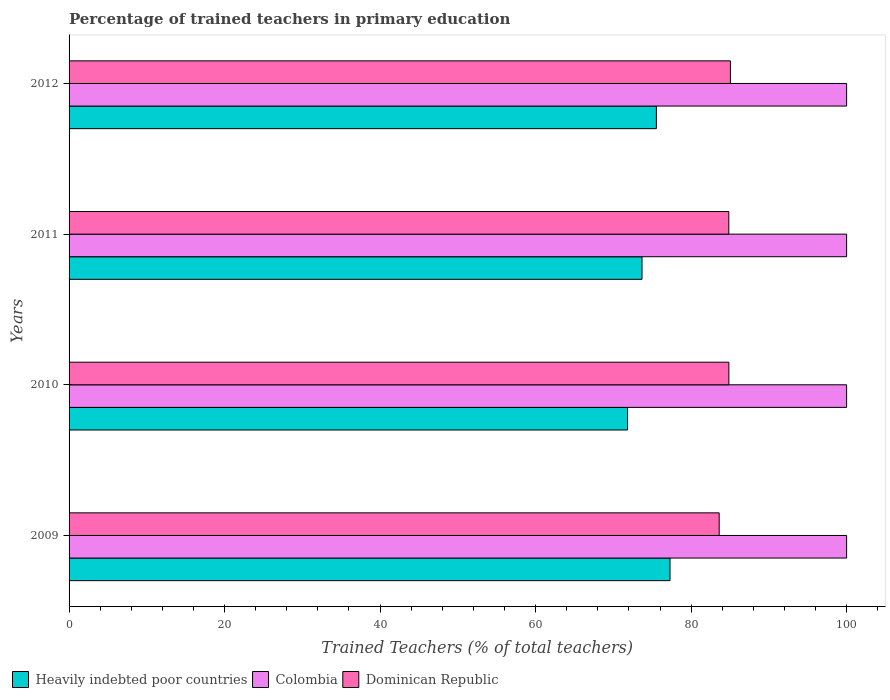How many different coloured bars are there?
Your response must be concise. 3. Are the number of bars on each tick of the Y-axis equal?
Give a very brief answer. Yes. How many bars are there on the 1st tick from the top?
Provide a short and direct response. 3. How many bars are there on the 4th tick from the bottom?
Provide a short and direct response. 3. What is the label of the 1st group of bars from the top?
Make the answer very short. 2012. In how many cases, is the number of bars for a given year not equal to the number of legend labels?
Make the answer very short. 0. What is the percentage of trained teachers in Heavily indebted poor countries in 2009?
Your answer should be very brief. 77.29. Across all years, what is the maximum percentage of trained teachers in Colombia?
Your response must be concise. 100. Across all years, what is the minimum percentage of trained teachers in Dominican Republic?
Your answer should be compact. 83.61. In which year was the percentage of trained teachers in Colombia maximum?
Your answer should be compact. 2009. In which year was the percentage of trained teachers in Dominican Republic minimum?
Provide a short and direct response. 2009. What is the total percentage of trained teachers in Colombia in the graph?
Give a very brief answer. 400. What is the difference between the percentage of trained teachers in Colombia in 2011 and the percentage of trained teachers in Heavily indebted poor countries in 2012?
Make the answer very short. 24.47. What is the average percentage of trained teachers in Dominican Republic per year?
Make the answer very short. 84.59. In the year 2012, what is the difference between the percentage of trained teachers in Colombia and percentage of trained teachers in Dominican Republic?
Ensure brevity in your answer.  14.95. What is the ratio of the percentage of trained teachers in Dominican Republic in 2009 to that in 2012?
Keep it short and to the point. 0.98. What is the difference between the highest and the second highest percentage of trained teachers in Colombia?
Ensure brevity in your answer.  0. What is the difference between the highest and the lowest percentage of trained teachers in Colombia?
Offer a very short reply. 0. In how many years, is the percentage of trained teachers in Colombia greater than the average percentage of trained teachers in Colombia taken over all years?
Your response must be concise. 0. What does the 3rd bar from the top in 2010 represents?
Provide a succinct answer. Heavily indebted poor countries. What does the 3rd bar from the bottom in 2010 represents?
Ensure brevity in your answer.  Dominican Republic. Is it the case that in every year, the sum of the percentage of trained teachers in Dominican Republic and percentage of trained teachers in Heavily indebted poor countries is greater than the percentage of trained teachers in Colombia?
Provide a short and direct response. Yes. Are all the bars in the graph horizontal?
Provide a short and direct response. Yes. What is the difference between two consecutive major ticks on the X-axis?
Offer a very short reply. 20. Does the graph contain any zero values?
Ensure brevity in your answer.  No. Does the graph contain grids?
Provide a succinct answer. No. Where does the legend appear in the graph?
Your answer should be very brief. Bottom left. How many legend labels are there?
Your answer should be very brief. 3. How are the legend labels stacked?
Offer a terse response. Horizontal. What is the title of the graph?
Give a very brief answer. Percentage of trained teachers in primary education. Does "Guyana" appear as one of the legend labels in the graph?
Offer a very short reply. No. What is the label or title of the X-axis?
Offer a terse response. Trained Teachers (% of total teachers). What is the Trained Teachers (% of total teachers) in Heavily indebted poor countries in 2009?
Ensure brevity in your answer.  77.29. What is the Trained Teachers (% of total teachers) in Colombia in 2009?
Offer a very short reply. 100. What is the Trained Teachers (% of total teachers) in Dominican Republic in 2009?
Make the answer very short. 83.61. What is the Trained Teachers (% of total teachers) of Heavily indebted poor countries in 2010?
Ensure brevity in your answer.  71.83. What is the Trained Teachers (% of total teachers) of Dominican Republic in 2010?
Offer a very short reply. 84.86. What is the Trained Teachers (% of total teachers) of Heavily indebted poor countries in 2011?
Your answer should be very brief. 73.69. What is the Trained Teachers (% of total teachers) of Dominican Republic in 2011?
Ensure brevity in your answer.  84.85. What is the Trained Teachers (% of total teachers) of Heavily indebted poor countries in 2012?
Provide a succinct answer. 75.53. What is the Trained Teachers (% of total teachers) of Dominican Republic in 2012?
Offer a terse response. 85.05. Across all years, what is the maximum Trained Teachers (% of total teachers) in Heavily indebted poor countries?
Offer a terse response. 77.29. Across all years, what is the maximum Trained Teachers (% of total teachers) of Dominican Republic?
Your answer should be very brief. 85.05. Across all years, what is the minimum Trained Teachers (% of total teachers) of Heavily indebted poor countries?
Make the answer very short. 71.83. Across all years, what is the minimum Trained Teachers (% of total teachers) in Colombia?
Provide a short and direct response. 100. Across all years, what is the minimum Trained Teachers (% of total teachers) of Dominican Republic?
Provide a succinct answer. 83.61. What is the total Trained Teachers (% of total teachers) of Heavily indebted poor countries in the graph?
Your answer should be compact. 298.33. What is the total Trained Teachers (% of total teachers) in Dominican Republic in the graph?
Provide a succinct answer. 338.37. What is the difference between the Trained Teachers (% of total teachers) of Heavily indebted poor countries in 2009 and that in 2010?
Make the answer very short. 5.46. What is the difference between the Trained Teachers (% of total teachers) in Colombia in 2009 and that in 2010?
Offer a very short reply. 0. What is the difference between the Trained Teachers (% of total teachers) of Dominican Republic in 2009 and that in 2010?
Make the answer very short. -1.25. What is the difference between the Trained Teachers (% of total teachers) of Heavily indebted poor countries in 2009 and that in 2011?
Make the answer very short. 3.6. What is the difference between the Trained Teachers (% of total teachers) in Dominican Republic in 2009 and that in 2011?
Offer a terse response. -1.24. What is the difference between the Trained Teachers (% of total teachers) of Heavily indebted poor countries in 2009 and that in 2012?
Your answer should be compact. 1.75. What is the difference between the Trained Teachers (% of total teachers) in Dominican Republic in 2009 and that in 2012?
Offer a terse response. -1.44. What is the difference between the Trained Teachers (% of total teachers) of Heavily indebted poor countries in 2010 and that in 2011?
Provide a succinct answer. -1.86. What is the difference between the Trained Teachers (% of total teachers) of Colombia in 2010 and that in 2011?
Ensure brevity in your answer.  0. What is the difference between the Trained Teachers (% of total teachers) of Dominican Republic in 2010 and that in 2011?
Give a very brief answer. 0.01. What is the difference between the Trained Teachers (% of total teachers) in Heavily indebted poor countries in 2010 and that in 2012?
Ensure brevity in your answer.  -3.71. What is the difference between the Trained Teachers (% of total teachers) in Colombia in 2010 and that in 2012?
Offer a very short reply. 0. What is the difference between the Trained Teachers (% of total teachers) of Dominican Republic in 2010 and that in 2012?
Give a very brief answer. -0.2. What is the difference between the Trained Teachers (% of total teachers) of Heavily indebted poor countries in 2011 and that in 2012?
Keep it short and to the point. -1.85. What is the difference between the Trained Teachers (% of total teachers) in Colombia in 2011 and that in 2012?
Keep it short and to the point. 0. What is the difference between the Trained Teachers (% of total teachers) in Dominican Republic in 2011 and that in 2012?
Give a very brief answer. -0.2. What is the difference between the Trained Teachers (% of total teachers) of Heavily indebted poor countries in 2009 and the Trained Teachers (% of total teachers) of Colombia in 2010?
Provide a succinct answer. -22.71. What is the difference between the Trained Teachers (% of total teachers) in Heavily indebted poor countries in 2009 and the Trained Teachers (% of total teachers) in Dominican Republic in 2010?
Give a very brief answer. -7.57. What is the difference between the Trained Teachers (% of total teachers) in Colombia in 2009 and the Trained Teachers (% of total teachers) in Dominican Republic in 2010?
Your response must be concise. 15.14. What is the difference between the Trained Teachers (% of total teachers) in Heavily indebted poor countries in 2009 and the Trained Teachers (% of total teachers) in Colombia in 2011?
Your response must be concise. -22.71. What is the difference between the Trained Teachers (% of total teachers) of Heavily indebted poor countries in 2009 and the Trained Teachers (% of total teachers) of Dominican Republic in 2011?
Your response must be concise. -7.56. What is the difference between the Trained Teachers (% of total teachers) in Colombia in 2009 and the Trained Teachers (% of total teachers) in Dominican Republic in 2011?
Give a very brief answer. 15.15. What is the difference between the Trained Teachers (% of total teachers) in Heavily indebted poor countries in 2009 and the Trained Teachers (% of total teachers) in Colombia in 2012?
Offer a terse response. -22.71. What is the difference between the Trained Teachers (% of total teachers) of Heavily indebted poor countries in 2009 and the Trained Teachers (% of total teachers) of Dominican Republic in 2012?
Give a very brief answer. -7.77. What is the difference between the Trained Teachers (% of total teachers) of Colombia in 2009 and the Trained Teachers (% of total teachers) of Dominican Republic in 2012?
Ensure brevity in your answer.  14.95. What is the difference between the Trained Teachers (% of total teachers) of Heavily indebted poor countries in 2010 and the Trained Teachers (% of total teachers) of Colombia in 2011?
Your answer should be very brief. -28.17. What is the difference between the Trained Teachers (% of total teachers) of Heavily indebted poor countries in 2010 and the Trained Teachers (% of total teachers) of Dominican Republic in 2011?
Provide a succinct answer. -13.02. What is the difference between the Trained Teachers (% of total teachers) in Colombia in 2010 and the Trained Teachers (% of total teachers) in Dominican Republic in 2011?
Your response must be concise. 15.15. What is the difference between the Trained Teachers (% of total teachers) of Heavily indebted poor countries in 2010 and the Trained Teachers (% of total teachers) of Colombia in 2012?
Give a very brief answer. -28.17. What is the difference between the Trained Teachers (% of total teachers) of Heavily indebted poor countries in 2010 and the Trained Teachers (% of total teachers) of Dominican Republic in 2012?
Give a very brief answer. -13.23. What is the difference between the Trained Teachers (% of total teachers) in Colombia in 2010 and the Trained Teachers (% of total teachers) in Dominican Republic in 2012?
Make the answer very short. 14.95. What is the difference between the Trained Teachers (% of total teachers) of Heavily indebted poor countries in 2011 and the Trained Teachers (% of total teachers) of Colombia in 2012?
Keep it short and to the point. -26.31. What is the difference between the Trained Teachers (% of total teachers) of Heavily indebted poor countries in 2011 and the Trained Teachers (% of total teachers) of Dominican Republic in 2012?
Your response must be concise. -11.37. What is the difference between the Trained Teachers (% of total teachers) of Colombia in 2011 and the Trained Teachers (% of total teachers) of Dominican Republic in 2012?
Make the answer very short. 14.95. What is the average Trained Teachers (% of total teachers) in Heavily indebted poor countries per year?
Keep it short and to the point. 74.58. What is the average Trained Teachers (% of total teachers) of Dominican Republic per year?
Provide a short and direct response. 84.59. In the year 2009, what is the difference between the Trained Teachers (% of total teachers) of Heavily indebted poor countries and Trained Teachers (% of total teachers) of Colombia?
Provide a short and direct response. -22.71. In the year 2009, what is the difference between the Trained Teachers (% of total teachers) in Heavily indebted poor countries and Trained Teachers (% of total teachers) in Dominican Republic?
Your answer should be very brief. -6.32. In the year 2009, what is the difference between the Trained Teachers (% of total teachers) in Colombia and Trained Teachers (% of total teachers) in Dominican Republic?
Your response must be concise. 16.39. In the year 2010, what is the difference between the Trained Teachers (% of total teachers) in Heavily indebted poor countries and Trained Teachers (% of total teachers) in Colombia?
Give a very brief answer. -28.17. In the year 2010, what is the difference between the Trained Teachers (% of total teachers) of Heavily indebted poor countries and Trained Teachers (% of total teachers) of Dominican Republic?
Offer a terse response. -13.03. In the year 2010, what is the difference between the Trained Teachers (% of total teachers) of Colombia and Trained Teachers (% of total teachers) of Dominican Republic?
Ensure brevity in your answer.  15.14. In the year 2011, what is the difference between the Trained Teachers (% of total teachers) of Heavily indebted poor countries and Trained Teachers (% of total teachers) of Colombia?
Offer a very short reply. -26.31. In the year 2011, what is the difference between the Trained Teachers (% of total teachers) of Heavily indebted poor countries and Trained Teachers (% of total teachers) of Dominican Republic?
Your answer should be compact. -11.16. In the year 2011, what is the difference between the Trained Teachers (% of total teachers) in Colombia and Trained Teachers (% of total teachers) in Dominican Republic?
Offer a terse response. 15.15. In the year 2012, what is the difference between the Trained Teachers (% of total teachers) of Heavily indebted poor countries and Trained Teachers (% of total teachers) of Colombia?
Offer a terse response. -24.47. In the year 2012, what is the difference between the Trained Teachers (% of total teachers) in Heavily indebted poor countries and Trained Teachers (% of total teachers) in Dominican Republic?
Offer a very short reply. -9.52. In the year 2012, what is the difference between the Trained Teachers (% of total teachers) in Colombia and Trained Teachers (% of total teachers) in Dominican Republic?
Keep it short and to the point. 14.95. What is the ratio of the Trained Teachers (% of total teachers) of Heavily indebted poor countries in 2009 to that in 2010?
Keep it short and to the point. 1.08. What is the ratio of the Trained Teachers (% of total teachers) in Colombia in 2009 to that in 2010?
Offer a terse response. 1. What is the ratio of the Trained Teachers (% of total teachers) of Dominican Republic in 2009 to that in 2010?
Your answer should be compact. 0.99. What is the ratio of the Trained Teachers (% of total teachers) of Heavily indebted poor countries in 2009 to that in 2011?
Offer a very short reply. 1.05. What is the ratio of the Trained Teachers (% of total teachers) in Dominican Republic in 2009 to that in 2011?
Provide a succinct answer. 0.99. What is the ratio of the Trained Teachers (% of total teachers) in Heavily indebted poor countries in 2009 to that in 2012?
Provide a succinct answer. 1.02. What is the ratio of the Trained Teachers (% of total teachers) in Heavily indebted poor countries in 2010 to that in 2011?
Make the answer very short. 0.97. What is the ratio of the Trained Teachers (% of total teachers) of Heavily indebted poor countries in 2010 to that in 2012?
Provide a short and direct response. 0.95. What is the ratio of the Trained Teachers (% of total teachers) of Colombia in 2010 to that in 2012?
Offer a terse response. 1. What is the ratio of the Trained Teachers (% of total teachers) in Heavily indebted poor countries in 2011 to that in 2012?
Keep it short and to the point. 0.98. What is the ratio of the Trained Teachers (% of total teachers) of Colombia in 2011 to that in 2012?
Keep it short and to the point. 1. What is the difference between the highest and the second highest Trained Teachers (% of total teachers) in Heavily indebted poor countries?
Make the answer very short. 1.75. What is the difference between the highest and the second highest Trained Teachers (% of total teachers) of Dominican Republic?
Offer a terse response. 0.2. What is the difference between the highest and the lowest Trained Teachers (% of total teachers) of Heavily indebted poor countries?
Give a very brief answer. 5.46. What is the difference between the highest and the lowest Trained Teachers (% of total teachers) of Colombia?
Make the answer very short. 0. What is the difference between the highest and the lowest Trained Teachers (% of total teachers) of Dominican Republic?
Provide a succinct answer. 1.44. 